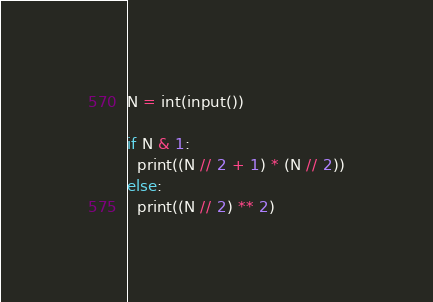Convert code to text. <code><loc_0><loc_0><loc_500><loc_500><_Python_>N = int(input())

if N & 1:
  print((N // 2 + 1) * (N // 2))
else:
  print((N // 2) ** 2)</code> 